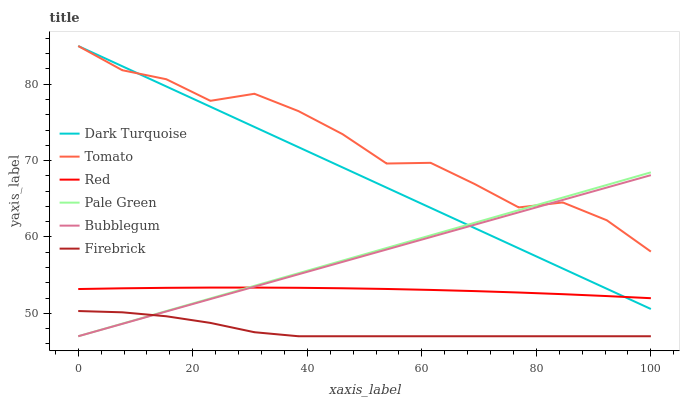Does Firebrick have the minimum area under the curve?
Answer yes or no. Yes. Does Tomato have the maximum area under the curve?
Answer yes or no. Yes. Does Dark Turquoise have the minimum area under the curve?
Answer yes or no. No. Does Dark Turquoise have the maximum area under the curve?
Answer yes or no. No. Is Bubblegum the smoothest?
Answer yes or no. Yes. Is Tomato the roughest?
Answer yes or no. Yes. Is Dark Turquoise the smoothest?
Answer yes or no. No. Is Dark Turquoise the roughest?
Answer yes or no. No. Does Firebrick have the lowest value?
Answer yes or no. Yes. Does Dark Turquoise have the lowest value?
Answer yes or no. No. Does Dark Turquoise have the highest value?
Answer yes or no. Yes. Does Firebrick have the highest value?
Answer yes or no. No. Is Firebrick less than Tomato?
Answer yes or no. Yes. Is Dark Turquoise greater than Firebrick?
Answer yes or no. Yes. Does Dark Turquoise intersect Tomato?
Answer yes or no. Yes. Is Dark Turquoise less than Tomato?
Answer yes or no. No. Is Dark Turquoise greater than Tomato?
Answer yes or no. No. Does Firebrick intersect Tomato?
Answer yes or no. No. 